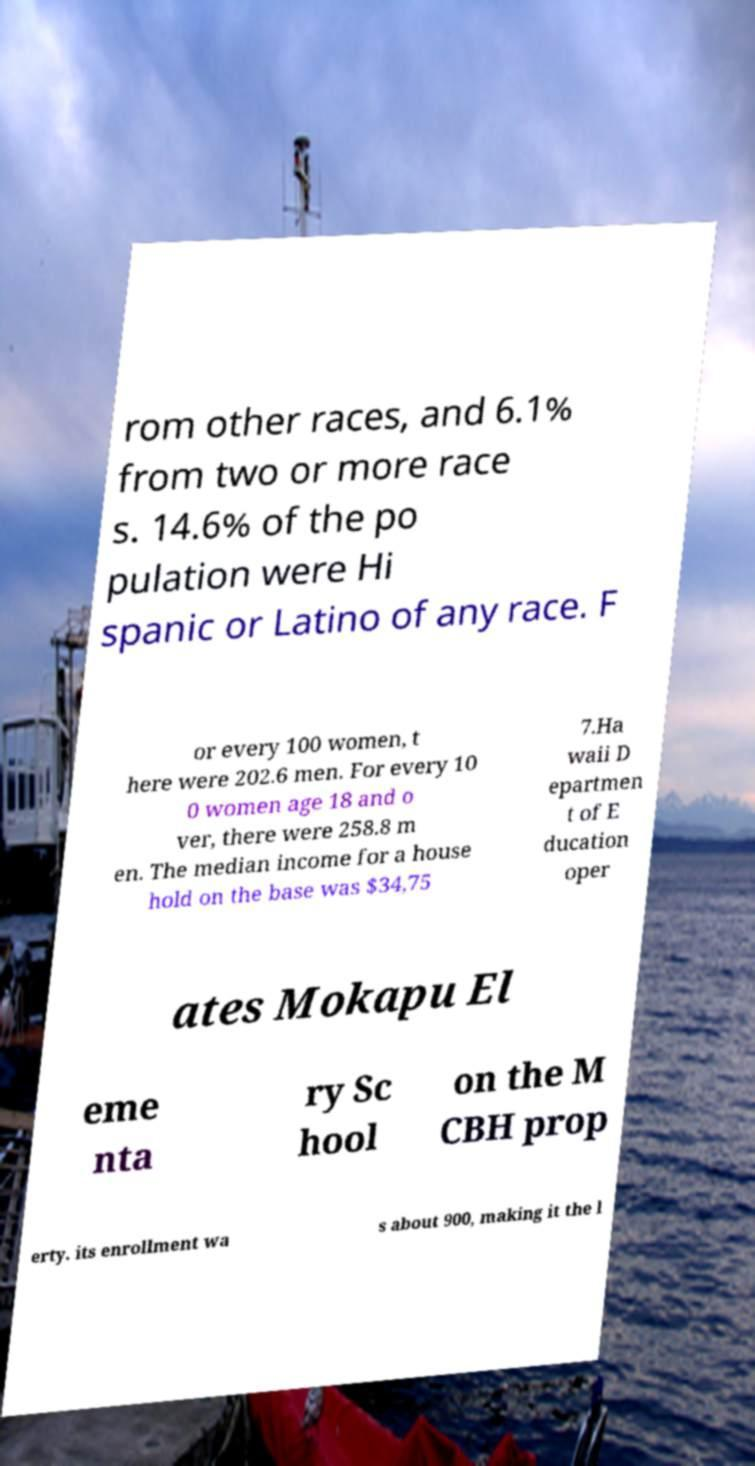I need the written content from this picture converted into text. Can you do that? rom other races, and 6.1% from two or more race s. 14.6% of the po pulation were Hi spanic or Latino of any race. F or every 100 women, t here were 202.6 men. For every 10 0 women age 18 and o ver, there were 258.8 m en. The median income for a house hold on the base was $34,75 7.Ha waii D epartmen t of E ducation oper ates Mokapu El eme nta ry Sc hool on the M CBH prop erty. its enrollment wa s about 900, making it the l 